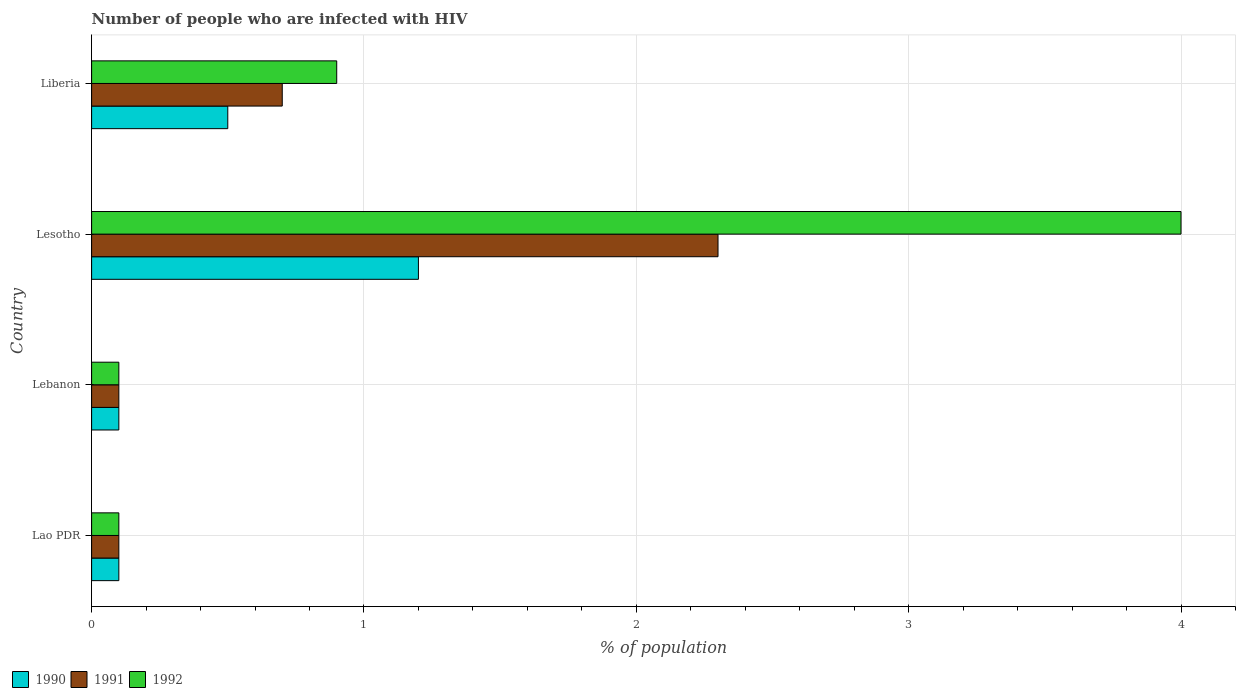How many different coloured bars are there?
Keep it short and to the point. 3. How many groups of bars are there?
Your response must be concise. 4. Are the number of bars on each tick of the Y-axis equal?
Offer a terse response. Yes. How many bars are there on the 3rd tick from the top?
Give a very brief answer. 3. How many bars are there on the 3rd tick from the bottom?
Keep it short and to the point. 3. What is the label of the 2nd group of bars from the top?
Provide a short and direct response. Lesotho. In how many cases, is the number of bars for a given country not equal to the number of legend labels?
Provide a short and direct response. 0. What is the percentage of HIV infected population in in 1990 in Lao PDR?
Your answer should be very brief. 0.1. Across all countries, what is the maximum percentage of HIV infected population in in 1990?
Your answer should be compact. 1.2. Across all countries, what is the minimum percentage of HIV infected population in in 1992?
Offer a terse response. 0.1. In which country was the percentage of HIV infected population in in 1991 maximum?
Give a very brief answer. Lesotho. In which country was the percentage of HIV infected population in in 1990 minimum?
Your answer should be compact. Lao PDR. What is the total percentage of HIV infected population in in 1992 in the graph?
Provide a short and direct response. 5.1. What is the difference between the percentage of HIV infected population in in 1992 in Lebanon and that in Lesotho?
Your response must be concise. -3.9. What is the difference between the percentage of HIV infected population in in 1991 in Lao PDR and the percentage of HIV infected population in in 1992 in Lebanon?
Offer a terse response. 0. What is the average percentage of HIV infected population in in 1991 per country?
Your answer should be compact. 0.8. What is the difference between the percentage of HIV infected population in in 1991 and percentage of HIV infected population in in 1992 in Lesotho?
Offer a terse response. -1.7. In how many countries, is the percentage of HIV infected population in in 1992 greater than 1.8 %?
Your response must be concise. 1. Is the percentage of HIV infected population in in 1991 in Lebanon less than that in Lesotho?
Your answer should be compact. Yes. What is the difference between the highest and the second highest percentage of HIV infected population in in 1990?
Provide a succinct answer. 0.7. What is the difference between the highest and the lowest percentage of HIV infected population in in 1991?
Your answer should be compact. 2.2. In how many countries, is the percentage of HIV infected population in in 1992 greater than the average percentage of HIV infected population in in 1992 taken over all countries?
Your answer should be compact. 1. Is the sum of the percentage of HIV infected population in in 1992 in Lebanon and Liberia greater than the maximum percentage of HIV infected population in in 1990 across all countries?
Your answer should be very brief. No. What does the 1st bar from the bottom in Lebanon represents?
Keep it short and to the point. 1990. Is it the case that in every country, the sum of the percentage of HIV infected population in in 1991 and percentage of HIV infected population in in 1990 is greater than the percentage of HIV infected population in in 1992?
Your answer should be compact. No. How many countries are there in the graph?
Your response must be concise. 4. What is the difference between two consecutive major ticks on the X-axis?
Your answer should be very brief. 1. Are the values on the major ticks of X-axis written in scientific E-notation?
Keep it short and to the point. No. Does the graph contain grids?
Your response must be concise. Yes. Where does the legend appear in the graph?
Provide a short and direct response. Bottom left. How many legend labels are there?
Provide a succinct answer. 3. How are the legend labels stacked?
Make the answer very short. Horizontal. What is the title of the graph?
Your answer should be very brief. Number of people who are infected with HIV. Does "1975" appear as one of the legend labels in the graph?
Give a very brief answer. No. What is the label or title of the X-axis?
Make the answer very short. % of population. What is the % of population of 1990 in Lao PDR?
Keep it short and to the point. 0.1. What is the % of population in 1991 in Lao PDR?
Give a very brief answer. 0.1. What is the % of population in 1991 in Lebanon?
Keep it short and to the point. 0.1. What is the % of population of 1992 in Lebanon?
Make the answer very short. 0.1. What is the % of population of 1990 in Lesotho?
Your answer should be very brief. 1.2. What is the % of population of 1992 in Lesotho?
Your answer should be compact. 4. What is the % of population of 1991 in Liberia?
Give a very brief answer. 0.7. Across all countries, what is the maximum % of population in 1991?
Make the answer very short. 2.3. Across all countries, what is the maximum % of population of 1992?
Provide a short and direct response. 4. Across all countries, what is the minimum % of population of 1992?
Your answer should be very brief. 0.1. What is the total % of population of 1990 in the graph?
Your answer should be compact. 1.9. What is the difference between the % of population of 1990 in Lao PDR and that in Lebanon?
Offer a terse response. 0. What is the difference between the % of population of 1990 in Lao PDR and that in Liberia?
Give a very brief answer. -0.4. What is the difference between the % of population of 1991 in Lao PDR and that in Liberia?
Provide a succinct answer. -0.6. What is the difference between the % of population in 1992 in Lao PDR and that in Liberia?
Make the answer very short. -0.8. What is the difference between the % of population in 1991 in Lebanon and that in Lesotho?
Keep it short and to the point. -2.2. What is the difference between the % of population in 1992 in Lebanon and that in Lesotho?
Provide a succinct answer. -3.9. What is the difference between the % of population in 1991 in Lesotho and that in Liberia?
Your answer should be compact. 1.6. What is the difference between the % of population of 1992 in Lesotho and that in Liberia?
Provide a succinct answer. 3.1. What is the difference between the % of population of 1990 in Lao PDR and the % of population of 1992 in Lebanon?
Keep it short and to the point. 0. What is the difference between the % of population in 1991 in Lao PDR and the % of population in 1992 in Lesotho?
Offer a very short reply. -3.9. What is the difference between the % of population of 1990 in Lao PDR and the % of population of 1992 in Liberia?
Your answer should be very brief. -0.8. What is the difference between the % of population of 1991 in Lao PDR and the % of population of 1992 in Liberia?
Keep it short and to the point. -0.8. What is the difference between the % of population in 1990 in Lebanon and the % of population in 1991 in Liberia?
Provide a short and direct response. -0.6. What is the difference between the % of population of 1990 in Lebanon and the % of population of 1992 in Liberia?
Provide a succinct answer. -0.8. What is the difference between the % of population of 1991 in Lebanon and the % of population of 1992 in Liberia?
Ensure brevity in your answer.  -0.8. What is the difference between the % of population of 1990 in Lesotho and the % of population of 1992 in Liberia?
Offer a terse response. 0.3. What is the difference between the % of population in 1991 in Lesotho and the % of population in 1992 in Liberia?
Your answer should be very brief. 1.4. What is the average % of population in 1990 per country?
Provide a short and direct response. 0.47. What is the average % of population of 1992 per country?
Keep it short and to the point. 1.27. What is the difference between the % of population of 1990 and % of population of 1991 in Lao PDR?
Give a very brief answer. 0. What is the difference between the % of population of 1991 and % of population of 1992 in Lao PDR?
Your answer should be compact. 0. What is the difference between the % of population in 1990 and % of population in 1991 in Lebanon?
Give a very brief answer. 0. What is the difference between the % of population of 1990 and % of population of 1992 in Lebanon?
Make the answer very short. 0. What is the difference between the % of population in 1991 and % of population in 1992 in Lebanon?
Keep it short and to the point. 0. What is the difference between the % of population of 1990 and % of population of 1991 in Lesotho?
Offer a very short reply. -1.1. What is the difference between the % of population in 1990 and % of population in 1992 in Lesotho?
Your answer should be compact. -2.8. What is the difference between the % of population of 1990 and % of population of 1991 in Liberia?
Your response must be concise. -0.2. What is the difference between the % of population of 1990 and % of population of 1992 in Liberia?
Keep it short and to the point. -0.4. What is the difference between the % of population of 1991 and % of population of 1992 in Liberia?
Keep it short and to the point. -0.2. What is the ratio of the % of population of 1991 in Lao PDR to that in Lebanon?
Give a very brief answer. 1. What is the ratio of the % of population of 1992 in Lao PDR to that in Lebanon?
Provide a succinct answer. 1. What is the ratio of the % of population of 1990 in Lao PDR to that in Lesotho?
Your answer should be very brief. 0.08. What is the ratio of the % of population in 1991 in Lao PDR to that in Lesotho?
Keep it short and to the point. 0.04. What is the ratio of the % of population of 1992 in Lao PDR to that in Lesotho?
Offer a terse response. 0.03. What is the ratio of the % of population of 1990 in Lao PDR to that in Liberia?
Make the answer very short. 0.2. What is the ratio of the % of population of 1991 in Lao PDR to that in Liberia?
Your answer should be very brief. 0.14. What is the ratio of the % of population in 1992 in Lao PDR to that in Liberia?
Ensure brevity in your answer.  0.11. What is the ratio of the % of population of 1990 in Lebanon to that in Lesotho?
Give a very brief answer. 0.08. What is the ratio of the % of population of 1991 in Lebanon to that in Lesotho?
Provide a succinct answer. 0.04. What is the ratio of the % of population of 1992 in Lebanon to that in Lesotho?
Your response must be concise. 0.03. What is the ratio of the % of population of 1990 in Lebanon to that in Liberia?
Ensure brevity in your answer.  0.2. What is the ratio of the % of population of 1991 in Lebanon to that in Liberia?
Your answer should be compact. 0.14. What is the ratio of the % of population of 1992 in Lebanon to that in Liberia?
Your response must be concise. 0.11. What is the ratio of the % of population in 1991 in Lesotho to that in Liberia?
Your answer should be very brief. 3.29. What is the ratio of the % of population of 1992 in Lesotho to that in Liberia?
Your answer should be compact. 4.44. What is the difference between the highest and the lowest % of population in 1990?
Make the answer very short. 1.1. What is the difference between the highest and the lowest % of population in 1992?
Keep it short and to the point. 3.9. 